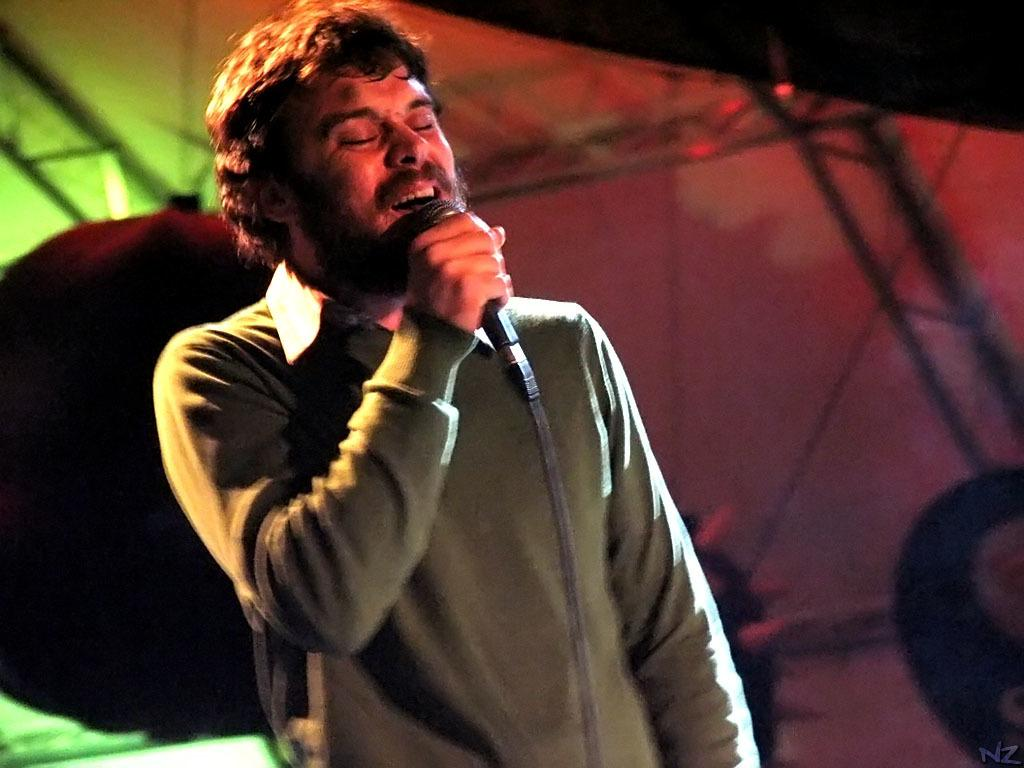What is the main subject of the picture? The main subject of the picture is a person. What is the person doing in the picture? The person is singing a song. What object is the person holding in the picture? The person is holding a microphone. What color is the shirt the person is wearing? The person is wearing a grey shirt. What type of guide is the person holding in the picture? There is no guide present in the image; the person is holding a microphone. Can you tell me how many stamps are on the person's shirt in the picture? There are no stamps visible on the person's shirt in the image; it is a grey shirt. 